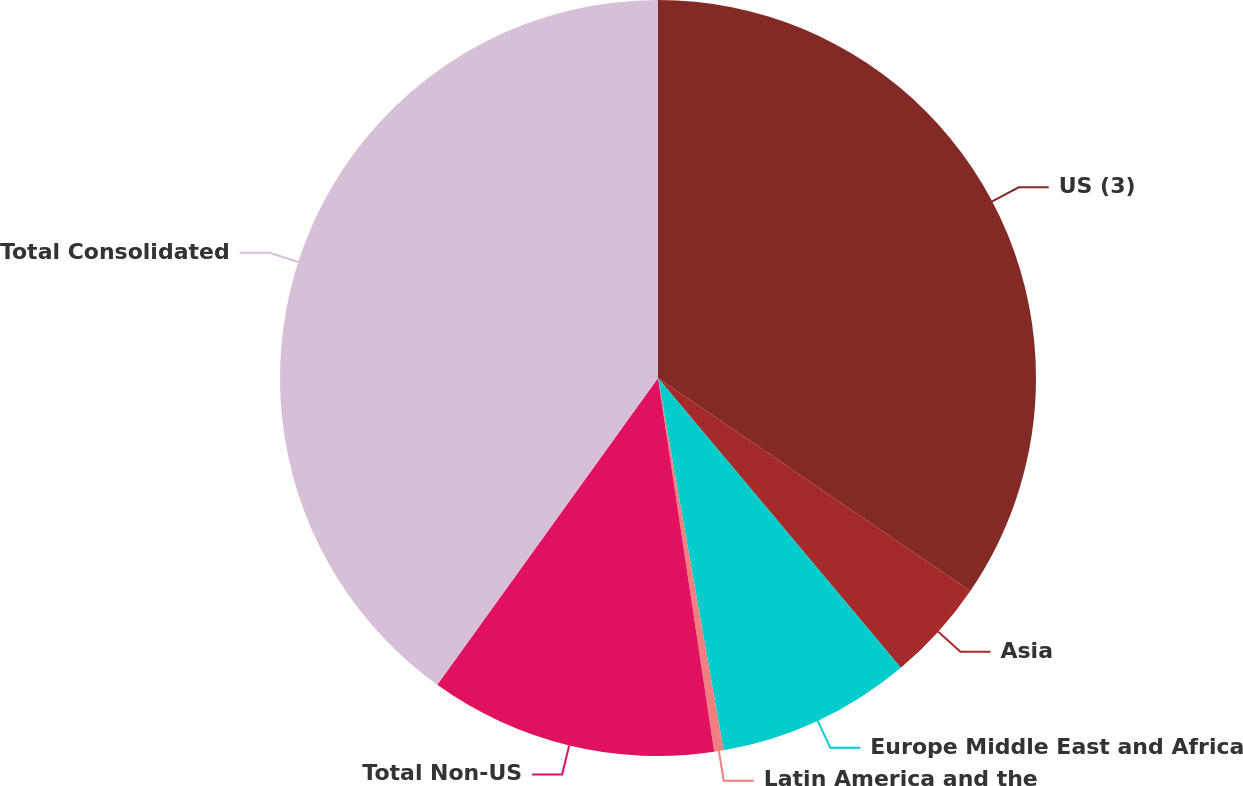Convert chart. <chart><loc_0><loc_0><loc_500><loc_500><pie_chart><fcel>US (3)<fcel>Asia<fcel>Europe Middle East and Africa<fcel>Latin America and the<fcel>Total Non-US<fcel>Total Consolidated<nl><fcel>34.52%<fcel>4.37%<fcel>8.33%<fcel>0.4%<fcel>12.3%<fcel>40.07%<nl></chart> 